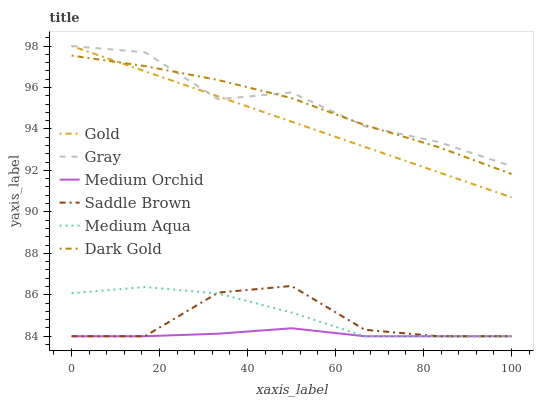Does Medium Orchid have the minimum area under the curve?
Answer yes or no. Yes. Does Gray have the maximum area under the curve?
Answer yes or no. Yes. Does Gold have the minimum area under the curve?
Answer yes or no. No. Does Gold have the maximum area under the curve?
Answer yes or no. No. Is Gold the smoothest?
Answer yes or no. Yes. Is Saddle Brown the roughest?
Answer yes or no. Yes. Is Dark Gold the smoothest?
Answer yes or no. No. Is Dark Gold the roughest?
Answer yes or no. No. Does Medium Orchid have the lowest value?
Answer yes or no. Yes. Does Gold have the lowest value?
Answer yes or no. No. Does Gold have the highest value?
Answer yes or no. Yes. Does Dark Gold have the highest value?
Answer yes or no. No. Is Saddle Brown less than Gold?
Answer yes or no. Yes. Is Gray greater than Saddle Brown?
Answer yes or no. Yes. Does Gold intersect Dark Gold?
Answer yes or no. Yes. Is Gold less than Dark Gold?
Answer yes or no. No. Is Gold greater than Dark Gold?
Answer yes or no. No. Does Saddle Brown intersect Gold?
Answer yes or no. No. 